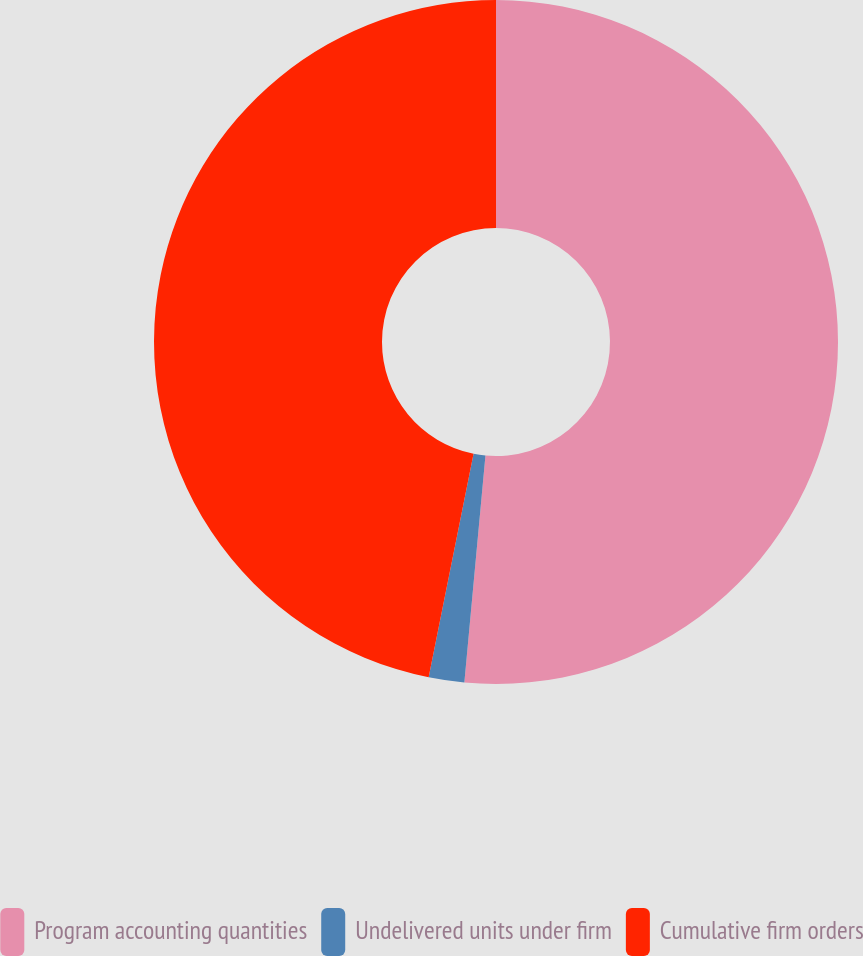<chart> <loc_0><loc_0><loc_500><loc_500><pie_chart><fcel>Program accounting quantities<fcel>Undelivered units under firm<fcel>Cumulative firm orders<nl><fcel>51.48%<fcel>1.68%<fcel>46.85%<nl></chart> 